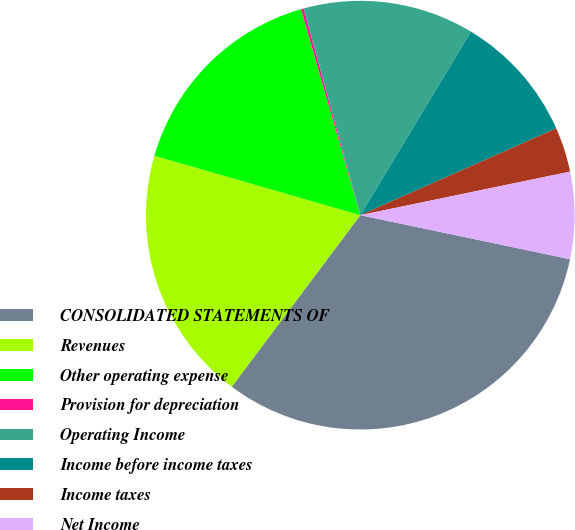<chart> <loc_0><loc_0><loc_500><loc_500><pie_chart><fcel>CONSOLIDATED STATEMENTS OF<fcel>Revenues<fcel>Other operating expense<fcel>Provision for depreciation<fcel>Operating Income<fcel>Income before income taxes<fcel>Income taxes<fcel>Net Income<nl><fcel>31.94%<fcel>19.24%<fcel>16.07%<fcel>0.2%<fcel>12.9%<fcel>9.72%<fcel>3.38%<fcel>6.55%<nl></chart> 